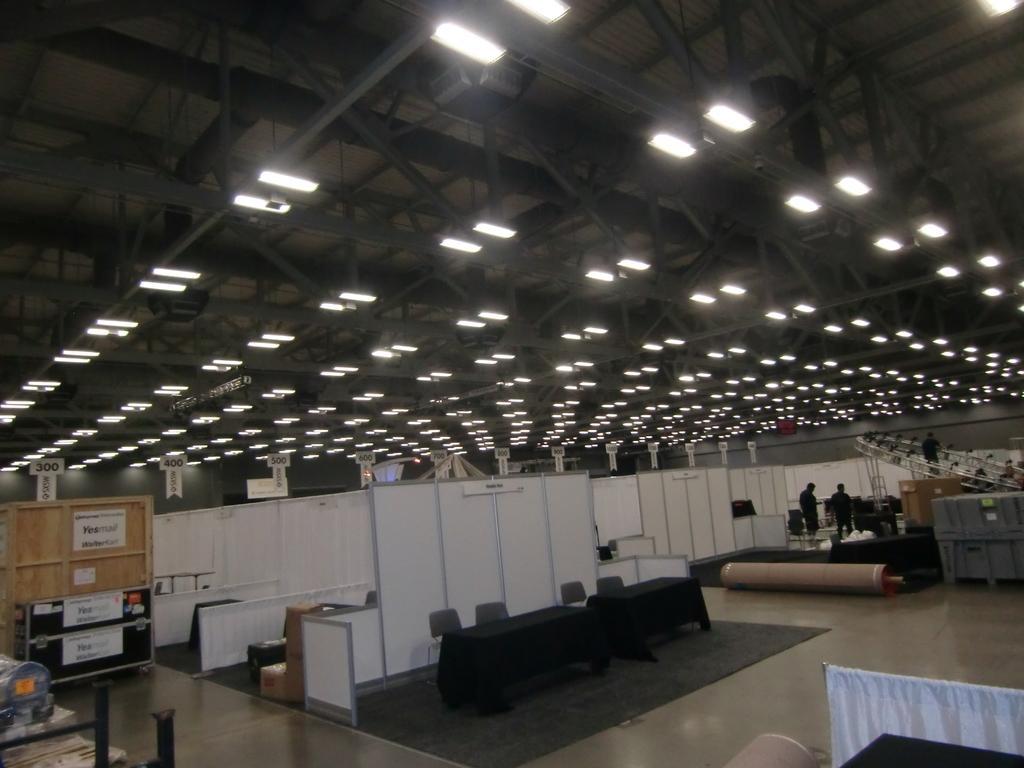How would you summarize this image in a sentence or two? In this image I can see two persons standing, in front I can see four chairs and a table, at the back there are few lights. At left I can see a board in brown color. 